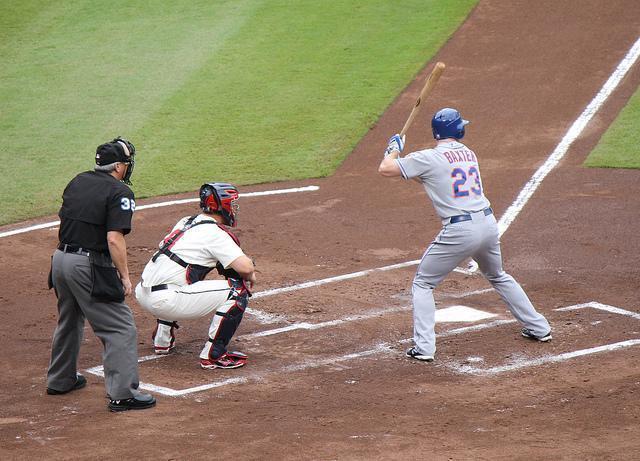How many people can you see?
Give a very brief answer. 3. How many baby bears are in the picture?
Give a very brief answer. 0. 